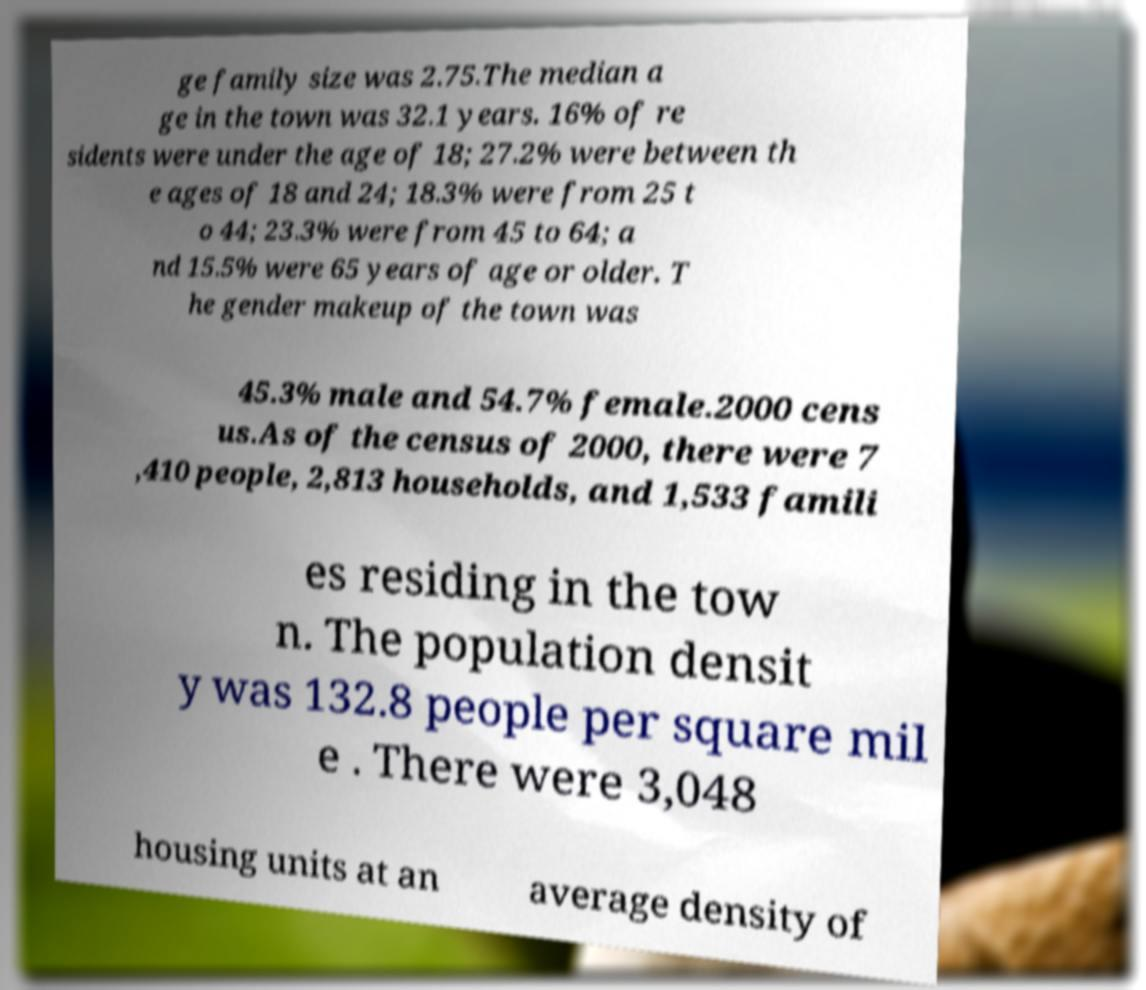Could you extract and type out the text from this image? ge family size was 2.75.The median a ge in the town was 32.1 years. 16% of re sidents were under the age of 18; 27.2% were between th e ages of 18 and 24; 18.3% were from 25 t o 44; 23.3% were from 45 to 64; a nd 15.5% were 65 years of age or older. T he gender makeup of the town was 45.3% male and 54.7% female.2000 cens us.As of the census of 2000, there were 7 ,410 people, 2,813 households, and 1,533 famili es residing in the tow n. The population densit y was 132.8 people per square mil e . There were 3,048 housing units at an average density of 